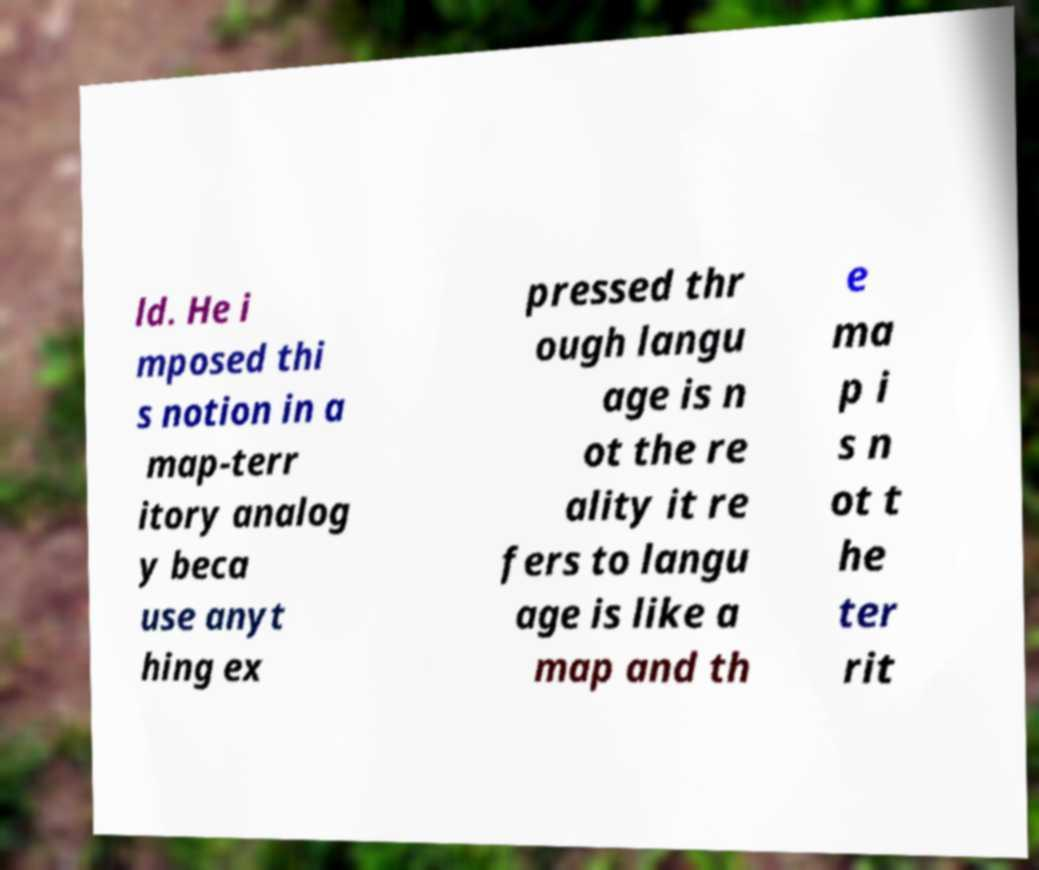Can you accurately transcribe the text from the provided image for me? ld. He i mposed thi s notion in a map-terr itory analog y beca use anyt hing ex pressed thr ough langu age is n ot the re ality it re fers to langu age is like a map and th e ma p i s n ot t he ter rit 